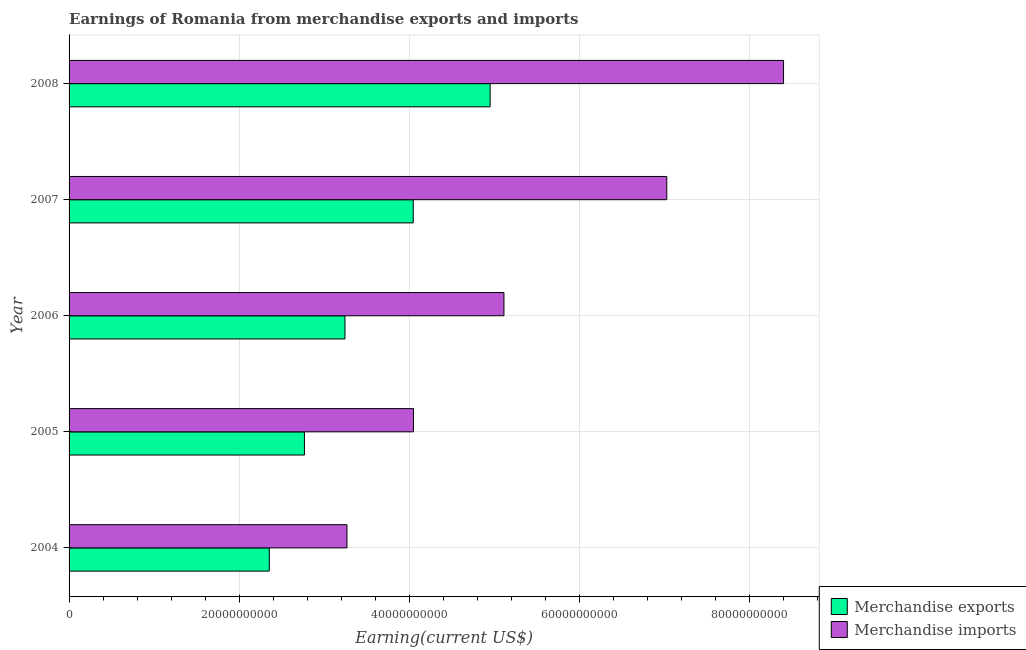How many different coloured bars are there?
Keep it short and to the point. 2. What is the earnings from merchandise imports in 2004?
Your answer should be compact. 3.27e+1. Across all years, what is the maximum earnings from merchandise imports?
Offer a very short reply. 8.41e+1. Across all years, what is the minimum earnings from merchandise exports?
Provide a succinct answer. 2.36e+1. In which year was the earnings from merchandise imports maximum?
Ensure brevity in your answer.  2008. What is the total earnings from merchandise exports in the graph?
Provide a short and direct response. 1.74e+11. What is the difference between the earnings from merchandise exports in 2007 and that in 2008?
Your answer should be very brief. -9.05e+09. What is the difference between the earnings from merchandise exports in 2008 and the earnings from merchandise imports in 2007?
Ensure brevity in your answer.  -2.08e+1. What is the average earnings from merchandise exports per year?
Ensure brevity in your answer.  3.47e+1. In the year 2005, what is the difference between the earnings from merchandise imports and earnings from merchandise exports?
Your answer should be compact. 1.28e+1. In how many years, is the earnings from merchandise exports greater than 60000000000 US$?
Keep it short and to the point. 0. What is the ratio of the earnings from merchandise exports in 2004 to that in 2005?
Your answer should be very brief. 0.85. Is the earnings from merchandise imports in 2005 less than that in 2007?
Offer a terse response. Yes. What is the difference between the highest and the second highest earnings from merchandise exports?
Provide a succinct answer. 9.05e+09. What is the difference between the highest and the lowest earnings from merchandise exports?
Your answer should be compact. 2.60e+1. In how many years, is the earnings from merchandise imports greater than the average earnings from merchandise imports taken over all years?
Your response must be concise. 2. How many bars are there?
Your answer should be very brief. 10. Are all the bars in the graph horizontal?
Provide a succinct answer. Yes. Are the values on the major ticks of X-axis written in scientific E-notation?
Provide a succinct answer. No. Does the graph contain any zero values?
Offer a terse response. No. How many legend labels are there?
Provide a succinct answer. 2. What is the title of the graph?
Give a very brief answer. Earnings of Romania from merchandise exports and imports. Does "Age 65(female)" appear as one of the legend labels in the graph?
Your answer should be compact. No. What is the label or title of the X-axis?
Your answer should be very brief. Earning(current US$). What is the label or title of the Y-axis?
Give a very brief answer. Year. What is the Earning(current US$) in Merchandise exports in 2004?
Your response must be concise. 2.36e+1. What is the Earning(current US$) in Merchandise imports in 2004?
Give a very brief answer. 3.27e+1. What is the Earning(current US$) in Merchandise exports in 2005?
Offer a very short reply. 2.77e+1. What is the Earning(current US$) of Merchandise imports in 2005?
Keep it short and to the point. 4.05e+1. What is the Earning(current US$) of Merchandise exports in 2006?
Your answer should be very brief. 3.25e+1. What is the Earning(current US$) in Merchandise imports in 2006?
Offer a terse response. 5.12e+1. What is the Earning(current US$) of Merchandise exports in 2007?
Your response must be concise. 4.05e+1. What is the Earning(current US$) of Merchandise imports in 2007?
Your response must be concise. 7.03e+1. What is the Earning(current US$) in Merchandise exports in 2008?
Your response must be concise. 4.95e+1. What is the Earning(current US$) of Merchandise imports in 2008?
Your answer should be very brief. 8.41e+1. Across all years, what is the maximum Earning(current US$) in Merchandise exports?
Give a very brief answer. 4.95e+1. Across all years, what is the maximum Earning(current US$) of Merchandise imports?
Provide a short and direct response. 8.41e+1. Across all years, what is the minimum Earning(current US$) in Merchandise exports?
Provide a succinct answer. 2.36e+1. Across all years, what is the minimum Earning(current US$) of Merchandise imports?
Your answer should be compact. 3.27e+1. What is the total Earning(current US$) of Merchandise exports in the graph?
Make the answer very short. 1.74e+11. What is the total Earning(current US$) in Merchandise imports in the graph?
Provide a succinct answer. 2.79e+11. What is the difference between the Earning(current US$) of Merchandise exports in 2004 and that in 2005?
Provide a succinct answer. -4.13e+09. What is the difference between the Earning(current US$) of Merchandise imports in 2004 and that in 2005?
Make the answer very short. -7.83e+09. What is the difference between the Earning(current US$) of Merchandise exports in 2004 and that in 2006?
Ensure brevity in your answer.  -8.90e+09. What is the difference between the Earning(current US$) in Merchandise imports in 2004 and that in 2006?
Provide a succinct answer. -1.85e+1. What is the difference between the Earning(current US$) in Merchandise exports in 2004 and that in 2007?
Your response must be concise. -1.69e+1. What is the difference between the Earning(current US$) of Merchandise imports in 2004 and that in 2007?
Keep it short and to the point. -3.76e+1. What is the difference between the Earning(current US$) in Merchandise exports in 2004 and that in 2008?
Provide a succinct answer. -2.60e+1. What is the difference between the Earning(current US$) in Merchandise imports in 2004 and that in 2008?
Your answer should be very brief. -5.14e+1. What is the difference between the Earning(current US$) of Merchandise exports in 2005 and that in 2006?
Your answer should be compact. -4.77e+09. What is the difference between the Earning(current US$) of Merchandise imports in 2005 and that in 2006?
Make the answer very short. -1.06e+1. What is the difference between the Earning(current US$) of Merchandise exports in 2005 and that in 2007?
Provide a short and direct response. -1.28e+1. What is the difference between the Earning(current US$) in Merchandise imports in 2005 and that in 2007?
Your answer should be compact. -2.98e+1. What is the difference between the Earning(current US$) in Merchandise exports in 2005 and that in 2008?
Give a very brief answer. -2.18e+1. What is the difference between the Earning(current US$) of Merchandise imports in 2005 and that in 2008?
Ensure brevity in your answer.  -4.35e+1. What is the difference between the Earning(current US$) in Merchandise exports in 2006 and that in 2007?
Make the answer very short. -8.03e+09. What is the difference between the Earning(current US$) in Merchandise imports in 2006 and that in 2007?
Ensure brevity in your answer.  -1.92e+1. What is the difference between the Earning(current US$) of Merchandise exports in 2006 and that in 2008?
Give a very brief answer. -1.71e+1. What is the difference between the Earning(current US$) in Merchandise imports in 2006 and that in 2008?
Provide a succinct answer. -3.29e+1. What is the difference between the Earning(current US$) of Merchandise exports in 2007 and that in 2008?
Your answer should be very brief. -9.05e+09. What is the difference between the Earning(current US$) of Merchandise imports in 2007 and that in 2008?
Make the answer very short. -1.37e+1. What is the difference between the Earning(current US$) in Merchandise exports in 2004 and the Earning(current US$) in Merchandise imports in 2005?
Keep it short and to the point. -1.70e+1. What is the difference between the Earning(current US$) in Merchandise exports in 2004 and the Earning(current US$) in Merchandise imports in 2006?
Your answer should be compact. -2.76e+1. What is the difference between the Earning(current US$) of Merchandise exports in 2004 and the Earning(current US$) of Merchandise imports in 2007?
Give a very brief answer. -4.68e+1. What is the difference between the Earning(current US$) in Merchandise exports in 2004 and the Earning(current US$) in Merchandise imports in 2008?
Make the answer very short. -6.05e+1. What is the difference between the Earning(current US$) of Merchandise exports in 2005 and the Earning(current US$) of Merchandise imports in 2006?
Offer a very short reply. -2.35e+1. What is the difference between the Earning(current US$) of Merchandise exports in 2005 and the Earning(current US$) of Merchandise imports in 2007?
Ensure brevity in your answer.  -4.26e+1. What is the difference between the Earning(current US$) in Merchandise exports in 2005 and the Earning(current US$) in Merchandise imports in 2008?
Keep it short and to the point. -5.64e+1. What is the difference between the Earning(current US$) of Merchandise exports in 2006 and the Earning(current US$) of Merchandise imports in 2007?
Your answer should be compact. -3.79e+1. What is the difference between the Earning(current US$) in Merchandise exports in 2006 and the Earning(current US$) in Merchandise imports in 2008?
Your answer should be very brief. -5.16e+1. What is the difference between the Earning(current US$) in Merchandise exports in 2007 and the Earning(current US$) in Merchandise imports in 2008?
Give a very brief answer. -4.36e+1. What is the average Earning(current US$) of Merchandise exports per year?
Keep it short and to the point. 3.47e+1. What is the average Earning(current US$) in Merchandise imports per year?
Offer a very short reply. 5.57e+1. In the year 2004, what is the difference between the Earning(current US$) in Merchandise exports and Earning(current US$) in Merchandise imports?
Your answer should be very brief. -9.14e+09. In the year 2005, what is the difference between the Earning(current US$) in Merchandise exports and Earning(current US$) in Merchandise imports?
Ensure brevity in your answer.  -1.28e+1. In the year 2006, what is the difference between the Earning(current US$) of Merchandise exports and Earning(current US$) of Merchandise imports?
Keep it short and to the point. -1.87e+1. In the year 2007, what is the difference between the Earning(current US$) of Merchandise exports and Earning(current US$) of Merchandise imports?
Your response must be concise. -2.98e+1. In the year 2008, what is the difference between the Earning(current US$) in Merchandise exports and Earning(current US$) in Merchandise imports?
Offer a terse response. -3.45e+1. What is the ratio of the Earning(current US$) of Merchandise exports in 2004 to that in 2005?
Offer a terse response. 0.85. What is the ratio of the Earning(current US$) in Merchandise imports in 2004 to that in 2005?
Offer a very short reply. 0.81. What is the ratio of the Earning(current US$) of Merchandise exports in 2004 to that in 2006?
Your response must be concise. 0.73. What is the ratio of the Earning(current US$) in Merchandise imports in 2004 to that in 2006?
Your response must be concise. 0.64. What is the ratio of the Earning(current US$) of Merchandise exports in 2004 to that in 2007?
Offer a terse response. 0.58. What is the ratio of the Earning(current US$) in Merchandise imports in 2004 to that in 2007?
Provide a succinct answer. 0.46. What is the ratio of the Earning(current US$) in Merchandise exports in 2004 to that in 2008?
Make the answer very short. 0.48. What is the ratio of the Earning(current US$) in Merchandise imports in 2004 to that in 2008?
Provide a short and direct response. 0.39. What is the ratio of the Earning(current US$) in Merchandise exports in 2005 to that in 2006?
Offer a very short reply. 0.85. What is the ratio of the Earning(current US$) of Merchandise imports in 2005 to that in 2006?
Your answer should be very brief. 0.79. What is the ratio of the Earning(current US$) in Merchandise exports in 2005 to that in 2007?
Ensure brevity in your answer.  0.68. What is the ratio of the Earning(current US$) of Merchandise imports in 2005 to that in 2007?
Provide a short and direct response. 0.58. What is the ratio of the Earning(current US$) of Merchandise exports in 2005 to that in 2008?
Make the answer very short. 0.56. What is the ratio of the Earning(current US$) in Merchandise imports in 2005 to that in 2008?
Offer a terse response. 0.48. What is the ratio of the Earning(current US$) in Merchandise exports in 2006 to that in 2007?
Provide a succinct answer. 0.8. What is the ratio of the Earning(current US$) in Merchandise imports in 2006 to that in 2007?
Provide a short and direct response. 0.73. What is the ratio of the Earning(current US$) in Merchandise exports in 2006 to that in 2008?
Keep it short and to the point. 0.66. What is the ratio of the Earning(current US$) of Merchandise imports in 2006 to that in 2008?
Give a very brief answer. 0.61. What is the ratio of the Earning(current US$) of Merchandise exports in 2007 to that in 2008?
Your response must be concise. 0.82. What is the ratio of the Earning(current US$) in Merchandise imports in 2007 to that in 2008?
Ensure brevity in your answer.  0.84. What is the difference between the highest and the second highest Earning(current US$) of Merchandise exports?
Provide a succinct answer. 9.05e+09. What is the difference between the highest and the second highest Earning(current US$) in Merchandise imports?
Keep it short and to the point. 1.37e+1. What is the difference between the highest and the lowest Earning(current US$) in Merchandise exports?
Ensure brevity in your answer.  2.60e+1. What is the difference between the highest and the lowest Earning(current US$) of Merchandise imports?
Ensure brevity in your answer.  5.14e+1. 